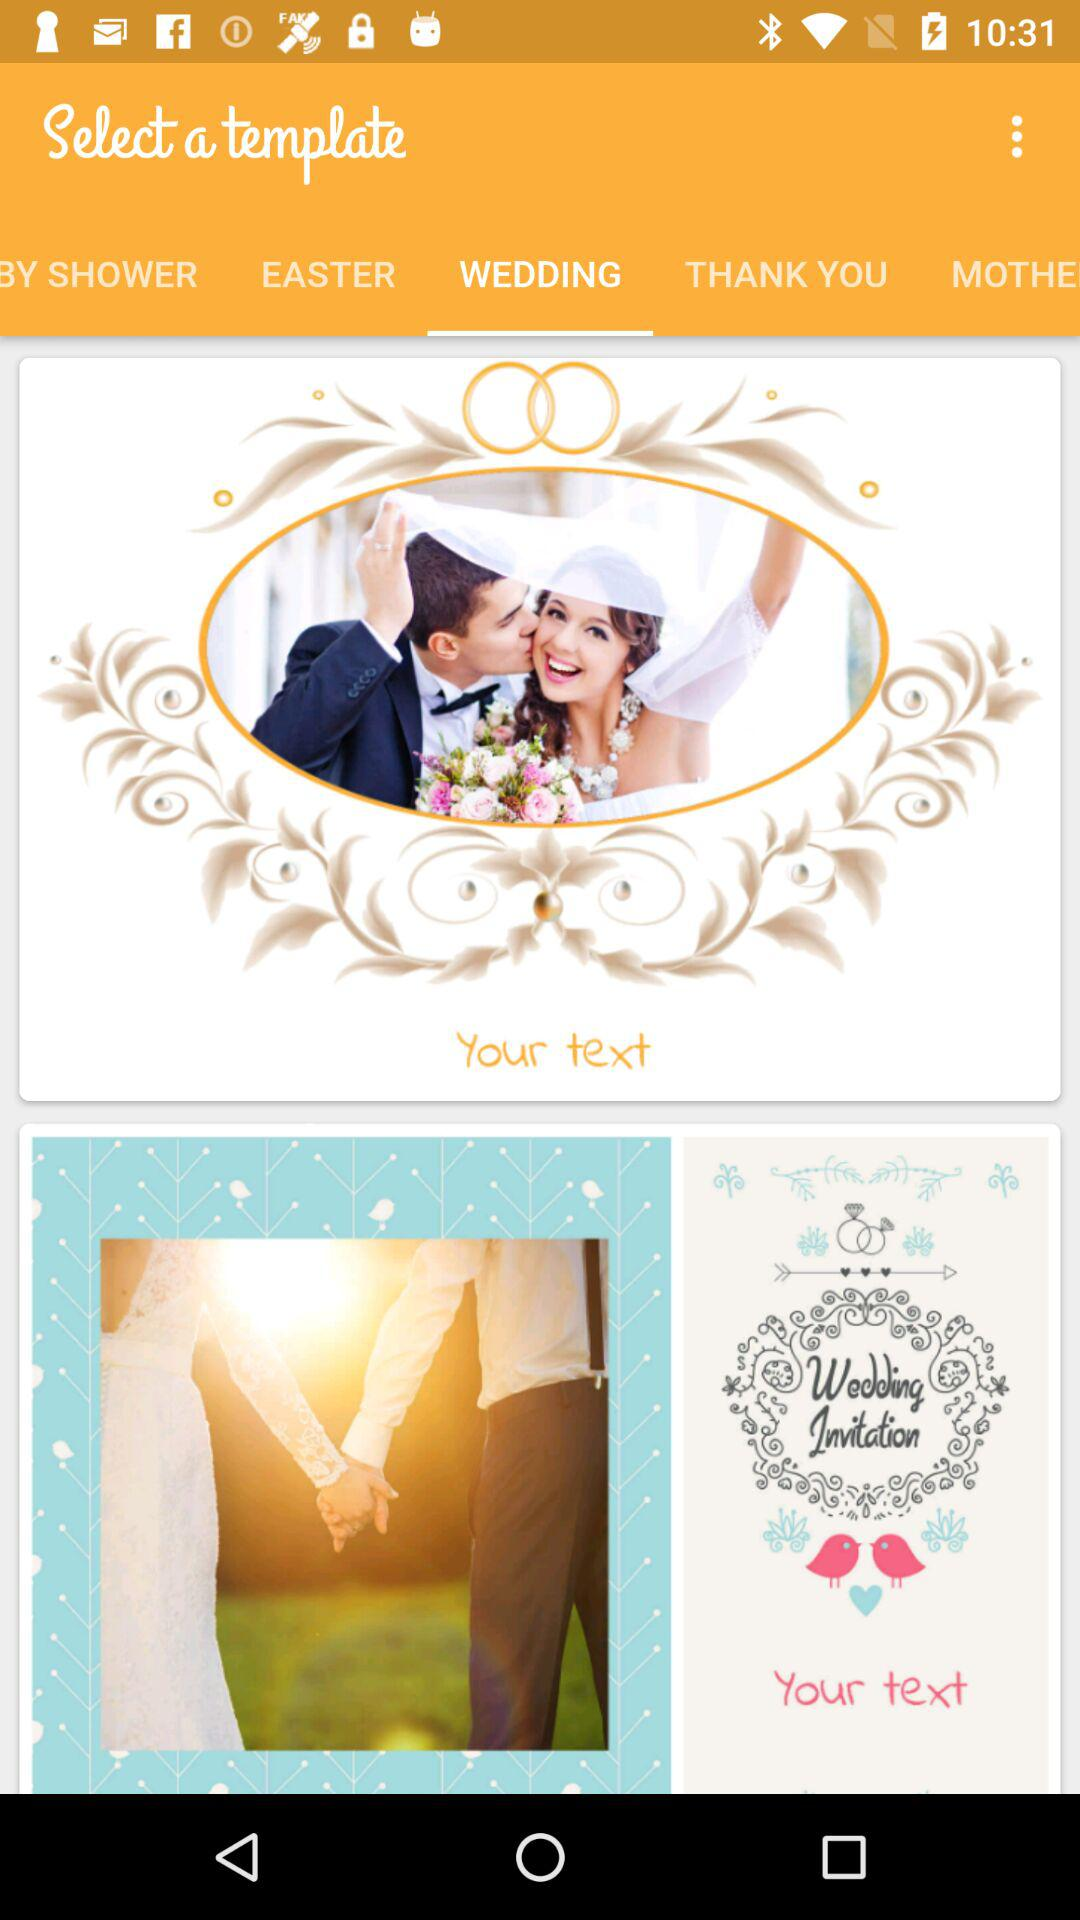Which tab of the application are we on? You are on the "WEDDING" tab of the application. 